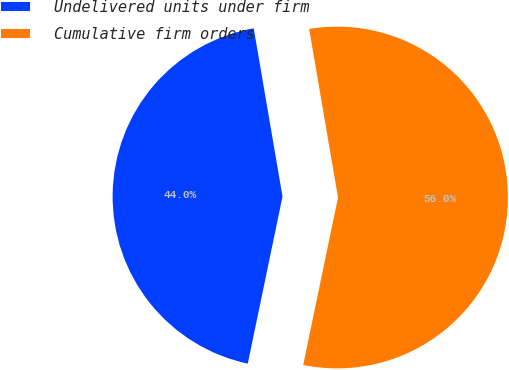<chart> <loc_0><loc_0><loc_500><loc_500><pie_chart><fcel>Undelivered units under firm<fcel>Cumulative firm orders<nl><fcel>44.04%<fcel>55.96%<nl></chart> 